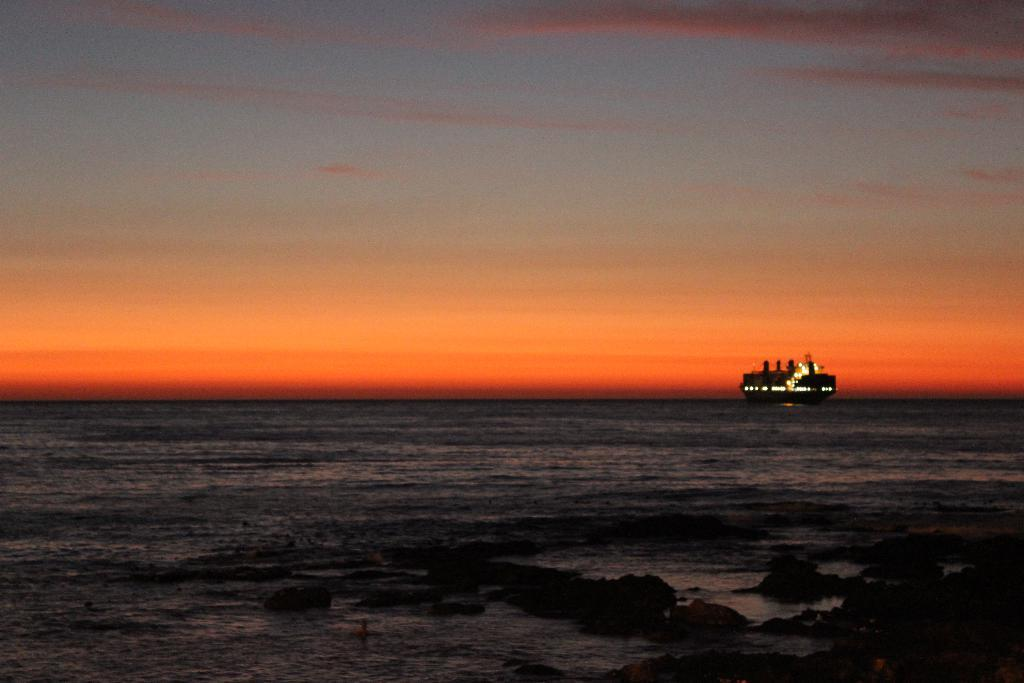What type of body of water is present in the image? There is a sea in the image. What else can be seen in the image besides the sea? The sky is visible at the top of the image. Where is the cave located in the image? There is no cave present in the image; it only features a sea and the sky. What type of washing machine can be seen in the image? There is no washing machine present in the image. 